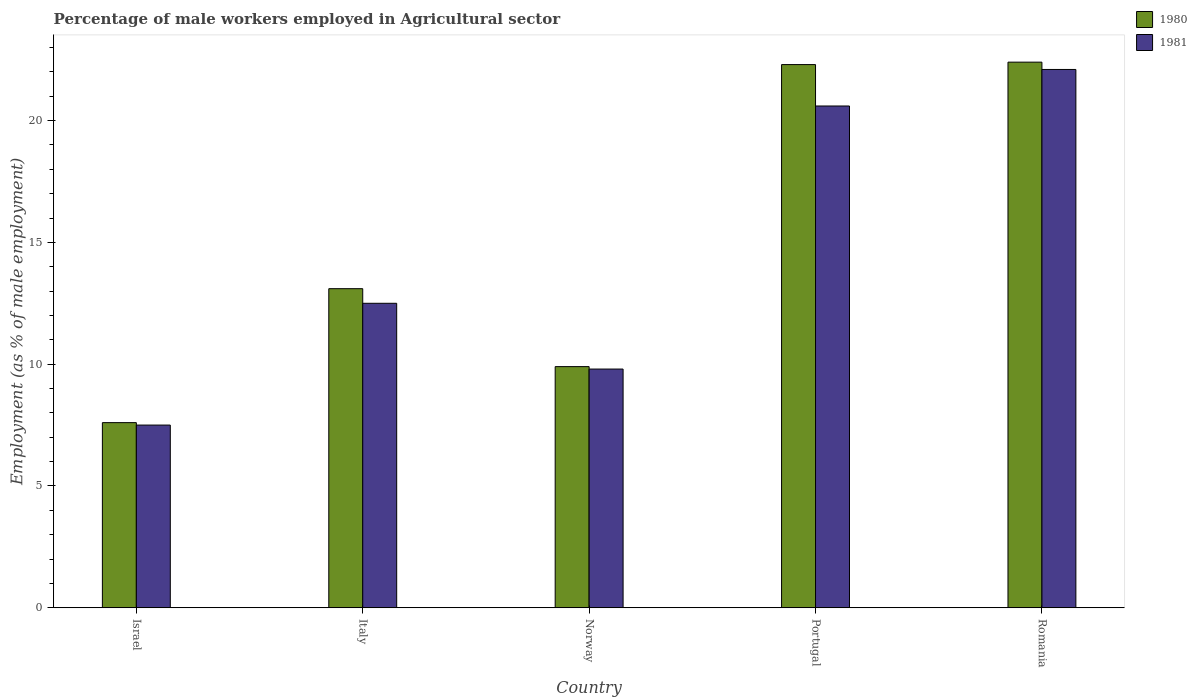How many groups of bars are there?
Your answer should be very brief. 5. How many bars are there on the 5th tick from the left?
Give a very brief answer. 2. What is the label of the 4th group of bars from the left?
Your answer should be very brief. Portugal. What is the percentage of male workers employed in Agricultural sector in 1980 in Portugal?
Provide a short and direct response. 22.3. Across all countries, what is the maximum percentage of male workers employed in Agricultural sector in 1981?
Ensure brevity in your answer.  22.1. Across all countries, what is the minimum percentage of male workers employed in Agricultural sector in 1981?
Give a very brief answer. 7.5. In which country was the percentage of male workers employed in Agricultural sector in 1980 maximum?
Keep it short and to the point. Romania. In which country was the percentage of male workers employed in Agricultural sector in 1980 minimum?
Offer a terse response. Israel. What is the total percentage of male workers employed in Agricultural sector in 1981 in the graph?
Make the answer very short. 72.5. What is the difference between the percentage of male workers employed in Agricultural sector in 1981 in Norway and that in Romania?
Your answer should be very brief. -12.3. What is the difference between the percentage of male workers employed in Agricultural sector in 1980 in Norway and the percentage of male workers employed in Agricultural sector in 1981 in Italy?
Provide a succinct answer. -2.6. What is the average percentage of male workers employed in Agricultural sector in 1981 per country?
Your answer should be compact. 14.5. What is the difference between the percentage of male workers employed in Agricultural sector of/in 1981 and percentage of male workers employed in Agricultural sector of/in 1980 in Israel?
Keep it short and to the point. -0.1. What is the ratio of the percentage of male workers employed in Agricultural sector in 1981 in Italy to that in Portugal?
Offer a very short reply. 0.61. What is the difference between the highest and the second highest percentage of male workers employed in Agricultural sector in 1980?
Your response must be concise. -9.3. What is the difference between the highest and the lowest percentage of male workers employed in Agricultural sector in 1981?
Provide a succinct answer. 14.6. Is the sum of the percentage of male workers employed in Agricultural sector in 1980 in Italy and Romania greater than the maximum percentage of male workers employed in Agricultural sector in 1981 across all countries?
Your response must be concise. Yes. What does the 2nd bar from the left in Italy represents?
Keep it short and to the point. 1981. How many bars are there?
Your response must be concise. 10. Are all the bars in the graph horizontal?
Offer a very short reply. No. How many countries are there in the graph?
Your answer should be compact. 5. What is the difference between two consecutive major ticks on the Y-axis?
Keep it short and to the point. 5. Does the graph contain grids?
Your answer should be very brief. No. Where does the legend appear in the graph?
Offer a very short reply. Top right. What is the title of the graph?
Keep it short and to the point. Percentage of male workers employed in Agricultural sector. Does "1978" appear as one of the legend labels in the graph?
Offer a terse response. No. What is the label or title of the X-axis?
Ensure brevity in your answer.  Country. What is the label or title of the Y-axis?
Provide a succinct answer. Employment (as % of male employment). What is the Employment (as % of male employment) in 1980 in Israel?
Keep it short and to the point. 7.6. What is the Employment (as % of male employment) of 1981 in Israel?
Provide a succinct answer. 7.5. What is the Employment (as % of male employment) of 1980 in Italy?
Make the answer very short. 13.1. What is the Employment (as % of male employment) of 1981 in Italy?
Ensure brevity in your answer.  12.5. What is the Employment (as % of male employment) in 1980 in Norway?
Offer a terse response. 9.9. What is the Employment (as % of male employment) of 1981 in Norway?
Ensure brevity in your answer.  9.8. What is the Employment (as % of male employment) of 1980 in Portugal?
Offer a very short reply. 22.3. What is the Employment (as % of male employment) in 1981 in Portugal?
Provide a short and direct response. 20.6. What is the Employment (as % of male employment) in 1980 in Romania?
Your answer should be very brief. 22.4. What is the Employment (as % of male employment) in 1981 in Romania?
Your response must be concise. 22.1. Across all countries, what is the maximum Employment (as % of male employment) in 1980?
Keep it short and to the point. 22.4. Across all countries, what is the maximum Employment (as % of male employment) of 1981?
Ensure brevity in your answer.  22.1. Across all countries, what is the minimum Employment (as % of male employment) of 1980?
Give a very brief answer. 7.6. What is the total Employment (as % of male employment) of 1980 in the graph?
Make the answer very short. 75.3. What is the total Employment (as % of male employment) of 1981 in the graph?
Your response must be concise. 72.5. What is the difference between the Employment (as % of male employment) in 1980 in Israel and that in Italy?
Provide a short and direct response. -5.5. What is the difference between the Employment (as % of male employment) of 1980 in Israel and that in Norway?
Your answer should be very brief. -2.3. What is the difference between the Employment (as % of male employment) in 1981 in Israel and that in Norway?
Give a very brief answer. -2.3. What is the difference between the Employment (as % of male employment) in 1980 in Israel and that in Portugal?
Give a very brief answer. -14.7. What is the difference between the Employment (as % of male employment) of 1980 in Israel and that in Romania?
Your answer should be very brief. -14.8. What is the difference between the Employment (as % of male employment) in 1981 in Israel and that in Romania?
Your answer should be very brief. -14.6. What is the difference between the Employment (as % of male employment) of 1980 in Italy and that in Norway?
Provide a short and direct response. 3.2. What is the difference between the Employment (as % of male employment) of 1981 in Italy and that in Norway?
Your answer should be compact. 2.7. What is the difference between the Employment (as % of male employment) of 1980 in Italy and that in Portugal?
Keep it short and to the point. -9.2. What is the difference between the Employment (as % of male employment) of 1980 in Italy and that in Romania?
Keep it short and to the point. -9.3. What is the difference between the Employment (as % of male employment) of 1980 in Norway and that in Romania?
Your answer should be very brief. -12.5. What is the difference between the Employment (as % of male employment) in 1980 in Israel and the Employment (as % of male employment) in 1981 in Norway?
Provide a short and direct response. -2.2. What is the difference between the Employment (as % of male employment) of 1980 in Israel and the Employment (as % of male employment) of 1981 in Romania?
Ensure brevity in your answer.  -14.5. What is the difference between the Employment (as % of male employment) in 1980 in Italy and the Employment (as % of male employment) in 1981 in Romania?
Your answer should be very brief. -9. What is the difference between the Employment (as % of male employment) of 1980 in Norway and the Employment (as % of male employment) of 1981 in Romania?
Make the answer very short. -12.2. What is the average Employment (as % of male employment) of 1980 per country?
Offer a very short reply. 15.06. What is the difference between the Employment (as % of male employment) of 1980 and Employment (as % of male employment) of 1981 in Israel?
Your answer should be very brief. 0.1. What is the ratio of the Employment (as % of male employment) in 1980 in Israel to that in Italy?
Ensure brevity in your answer.  0.58. What is the ratio of the Employment (as % of male employment) in 1981 in Israel to that in Italy?
Provide a succinct answer. 0.6. What is the ratio of the Employment (as % of male employment) in 1980 in Israel to that in Norway?
Provide a succinct answer. 0.77. What is the ratio of the Employment (as % of male employment) in 1981 in Israel to that in Norway?
Give a very brief answer. 0.77. What is the ratio of the Employment (as % of male employment) of 1980 in Israel to that in Portugal?
Provide a succinct answer. 0.34. What is the ratio of the Employment (as % of male employment) of 1981 in Israel to that in Portugal?
Provide a succinct answer. 0.36. What is the ratio of the Employment (as % of male employment) in 1980 in Israel to that in Romania?
Your answer should be compact. 0.34. What is the ratio of the Employment (as % of male employment) of 1981 in Israel to that in Romania?
Keep it short and to the point. 0.34. What is the ratio of the Employment (as % of male employment) in 1980 in Italy to that in Norway?
Provide a succinct answer. 1.32. What is the ratio of the Employment (as % of male employment) in 1981 in Italy to that in Norway?
Provide a short and direct response. 1.28. What is the ratio of the Employment (as % of male employment) of 1980 in Italy to that in Portugal?
Offer a terse response. 0.59. What is the ratio of the Employment (as % of male employment) of 1981 in Italy to that in Portugal?
Your answer should be compact. 0.61. What is the ratio of the Employment (as % of male employment) in 1980 in Italy to that in Romania?
Provide a short and direct response. 0.58. What is the ratio of the Employment (as % of male employment) of 1981 in Italy to that in Romania?
Your response must be concise. 0.57. What is the ratio of the Employment (as % of male employment) of 1980 in Norway to that in Portugal?
Ensure brevity in your answer.  0.44. What is the ratio of the Employment (as % of male employment) in 1981 in Norway to that in Portugal?
Make the answer very short. 0.48. What is the ratio of the Employment (as % of male employment) of 1980 in Norway to that in Romania?
Provide a short and direct response. 0.44. What is the ratio of the Employment (as % of male employment) of 1981 in Norway to that in Romania?
Make the answer very short. 0.44. What is the ratio of the Employment (as % of male employment) of 1981 in Portugal to that in Romania?
Offer a very short reply. 0.93. What is the difference between the highest and the second highest Employment (as % of male employment) in 1981?
Ensure brevity in your answer.  1.5. What is the difference between the highest and the lowest Employment (as % of male employment) in 1980?
Ensure brevity in your answer.  14.8. 